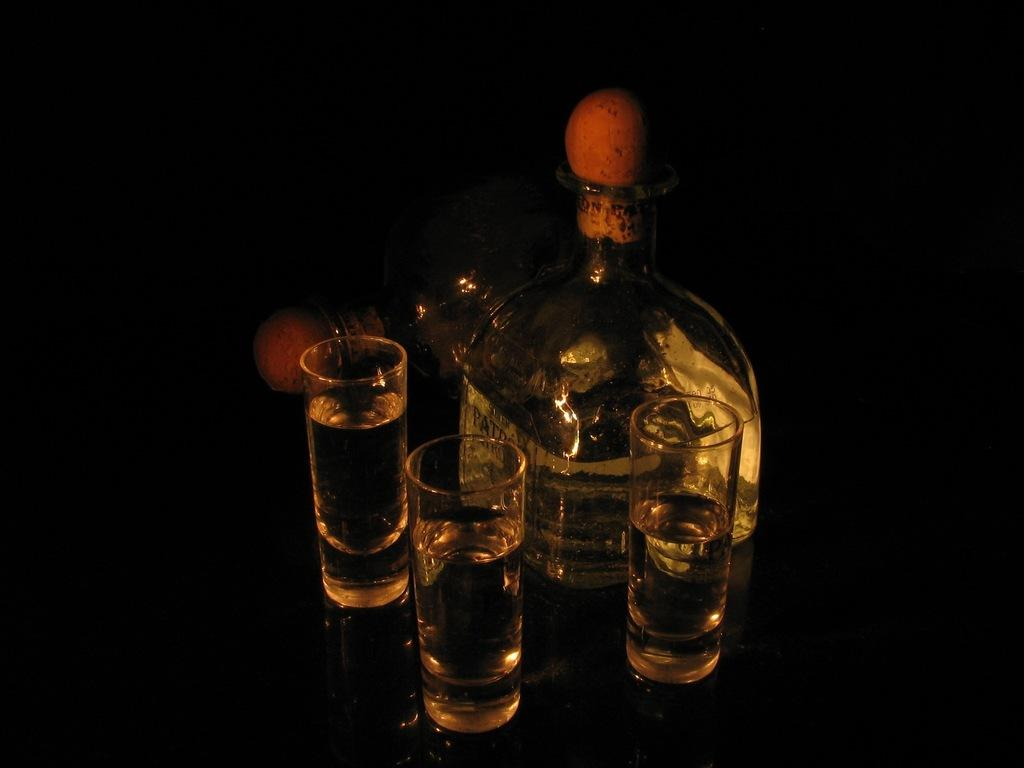How many glasses are on the table in the image? There are three glasses on the table. What other objects can be seen on the table? There are two glass bottles on the table. Can you describe the object behind the bottles? There is a black-colored object behind the bottles, which is likely a bottle or container. What year is depicted on the label of the bottle in the image? There is no label or year visible on the bottles in the image. How does the grip of the glasses in the image feel? The image does not provide information about the texture or feel of the glasses, so it cannot be determined from the image. 